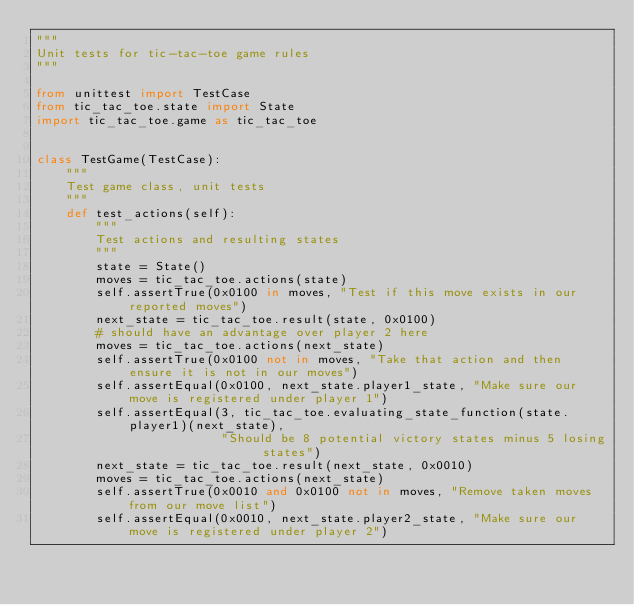<code> <loc_0><loc_0><loc_500><loc_500><_Python_>"""
Unit tests for tic-tac-toe game rules
"""

from unittest import TestCase
from tic_tac_toe.state import State
import tic_tac_toe.game as tic_tac_toe


class TestGame(TestCase):
    """
    Test game class, unit tests
    """
    def test_actions(self):
        """
        Test actions and resulting states
        """
        state = State()
        moves = tic_tac_toe.actions(state)
        self.assertTrue(0x0100 in moves, "Test if this move exists in our reported moves")
        next_state = tic_tac_toe.result(state, 0x0100)
        # should have an advantage over player 2 here
        moves = tic_tac_toe.actions(next_state)
        self.assertTrue(0x0100 not in moves, "Take that action and then ensure it is not in our moves")
        self.assertEqual(0x0100, next_state.player1_state, "Make sure our move is registered under player 1")
        self.assertEqual(3, tic_tac_toe.evaluating_state_function(state.player1)(next_state),
                         "Should be 8 potential victory states minus 5 losing states")
        next_state = tic_tac_toe.result(next_state, 0x0010)
        moves = tic_tac_toe.actions(next_state)
        self.assertTrue(0x0010 and 0x0100 not in moves, "Remove taken moves from our move list")
        self.assertEqual(0x0010, next_state.player2_state, "Make sure our move is registered under player 2")</code> 